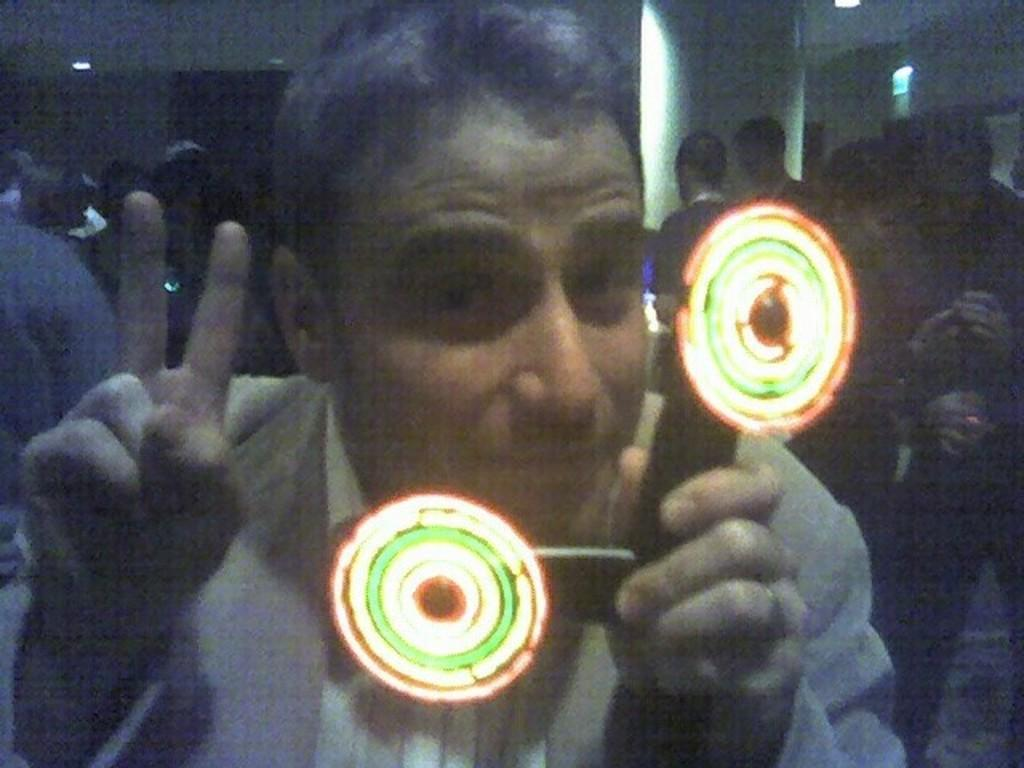Who is the main subject in the image? There is a man in the image. What is the man holding in his hand? The man is holding a toy with lights in his hand. Can you describe the background of the image? The background appears blurred, and there are many people in the background. How many apples are on the tin in the image? There is no tin or apples present in the image. What type of whistle can be heard in the background of the image? There is no whistle sound in the image, and no whistle is visible. 